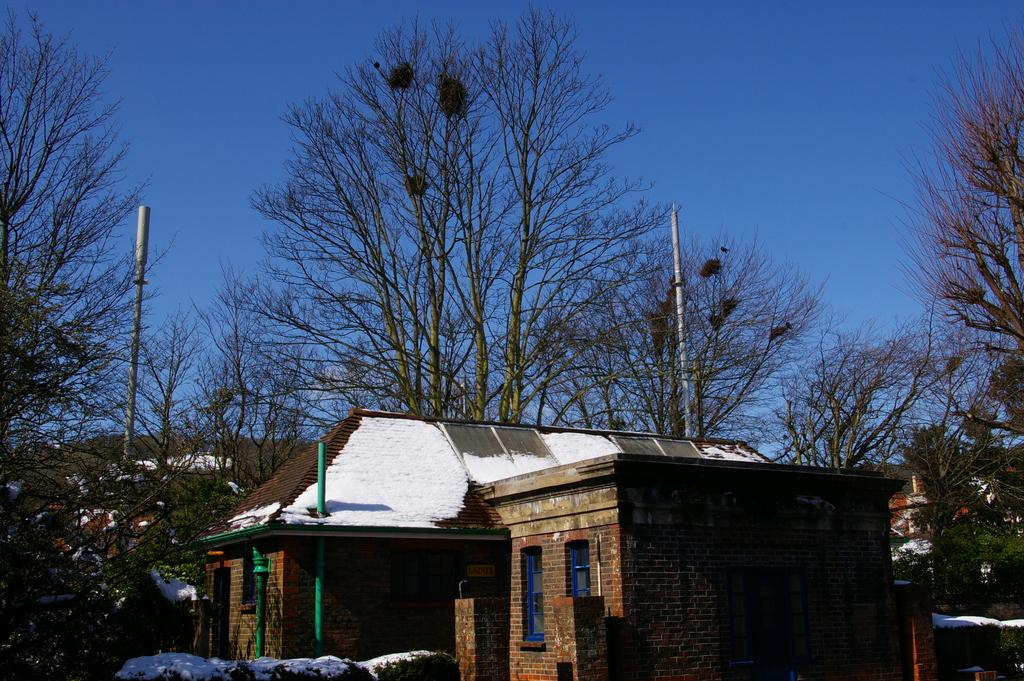What type of structures can be seen in the image? There are buildings in the image. What other natural elements are present in the image? There are trees in the image. What are the poles used for in the image? The purpose of the poles is not specified, but they are visible in the image. How is the snow affecting the appearance of the buildings and trees in the image? Snow is present on the buildings and trees, giving them a white, snow-covered appearance. What color is the sky in the image? The sky is blue in the image. What type of camera was used to take the image from a specific angle and distance? The type of camera, angle, and distance used to take the image are not mentioned in the provided facts. 